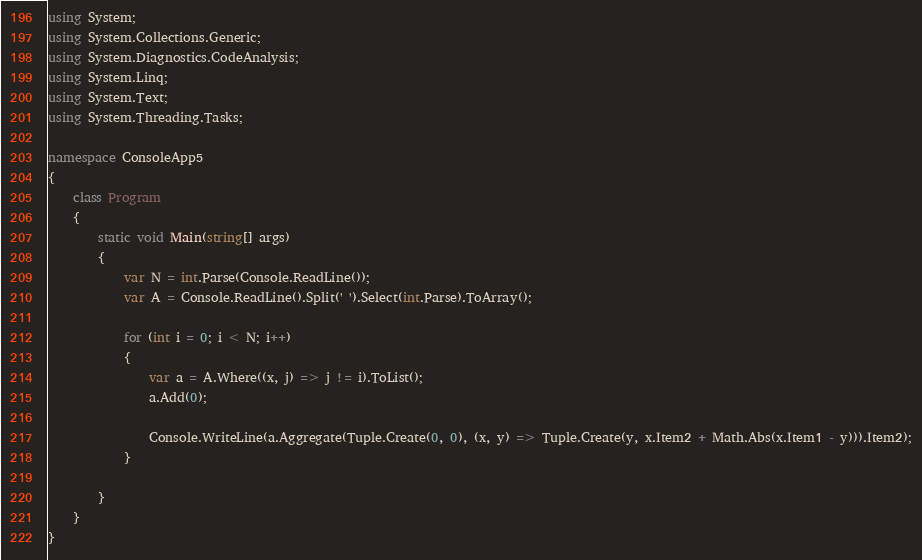Convert code to text. <code><loc_0><loc_0><loc_500><loc_500><_C#_>using System;
using System.Collections.Generic;
using System.Diagnostics.CodeAnalysis;
using System.Linq;
using System.Text;
using System.Threading.Tasks;

namespace ConsoleApp5
{
    class Program
    {
        static void Main(string[] args)
        {
            var N = int.Parse(Console.ReadLine());
            var A = Console.ReadLine().Split(' ').Select(int.Parse).ToArray();

            for (int i = 0; i < N; i++)
            {
                var a = A.Where((x, j) => j != i).ToList();
                a.Add(0);

                Console.WriteLine(a.Aggregate(Tuple.Create(0, 0), (x, y) => Tuple.Create(y, x.Item2 + Math.Abs(x.Item1 - y))).Item2);
            }

        }
    }
}
</code> 